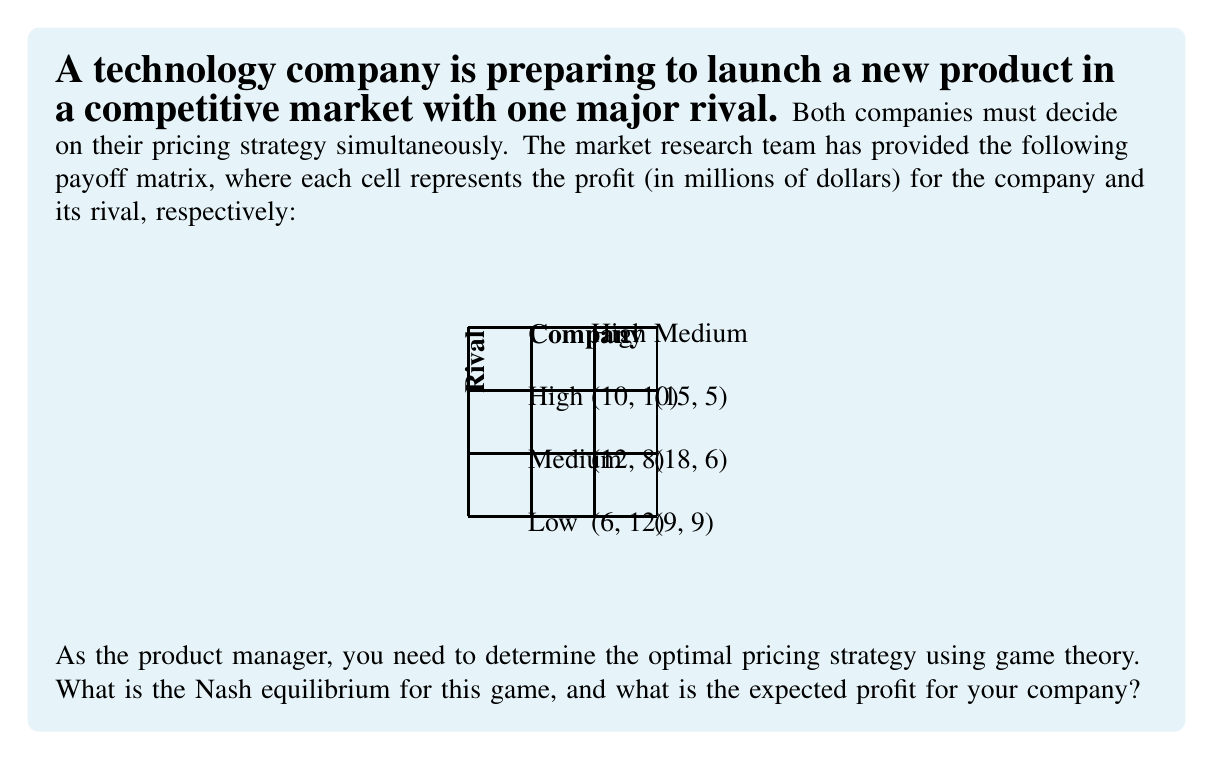Can you answer this question? To solve this problem, we need to find the Nash equilibrium of the game. A Nash equilibrium is a set of strategies where no player can unilaterally improve their outcome by changing their strategy.

Step 1: Identify dominant strategies
First, we check if there are any dominant strategies for either player.

For the Company:
- If Rival chooses High: Medium (12) > High (10) > Low (6)
- If Rival chooses Medium: Medium (18) > High (15) > Low (9)

Medium is always better for the Company, so it's a dominant strategy.

For the Rival:
- If Company chooses High: High (10) > Medium (5)
- If Company chooses Medium: High (8) > Medium (6)
- If Company chooses Low: High (12) > Medium (9)

High is always better for the Rival, so it's a dominant strategy.

Step 2: Determine the Nash equilibrium
Since both players have dominant strategies, the Nash equilibrium is where both players play their dominant strategies. This occurs when:

Company chooses: Medium
Rival chooses: High

Step 3: Calculate the expected profit
At the Nash equilibrium (Medium, High), the payoff for the Company is $12 million.

Therefore, the Nash equilibrium is (Medium, High), and the expected profit for the Company is $12 million.
Answer: Nash equilibrium: (Medium, High); Expected profit: $12 million 